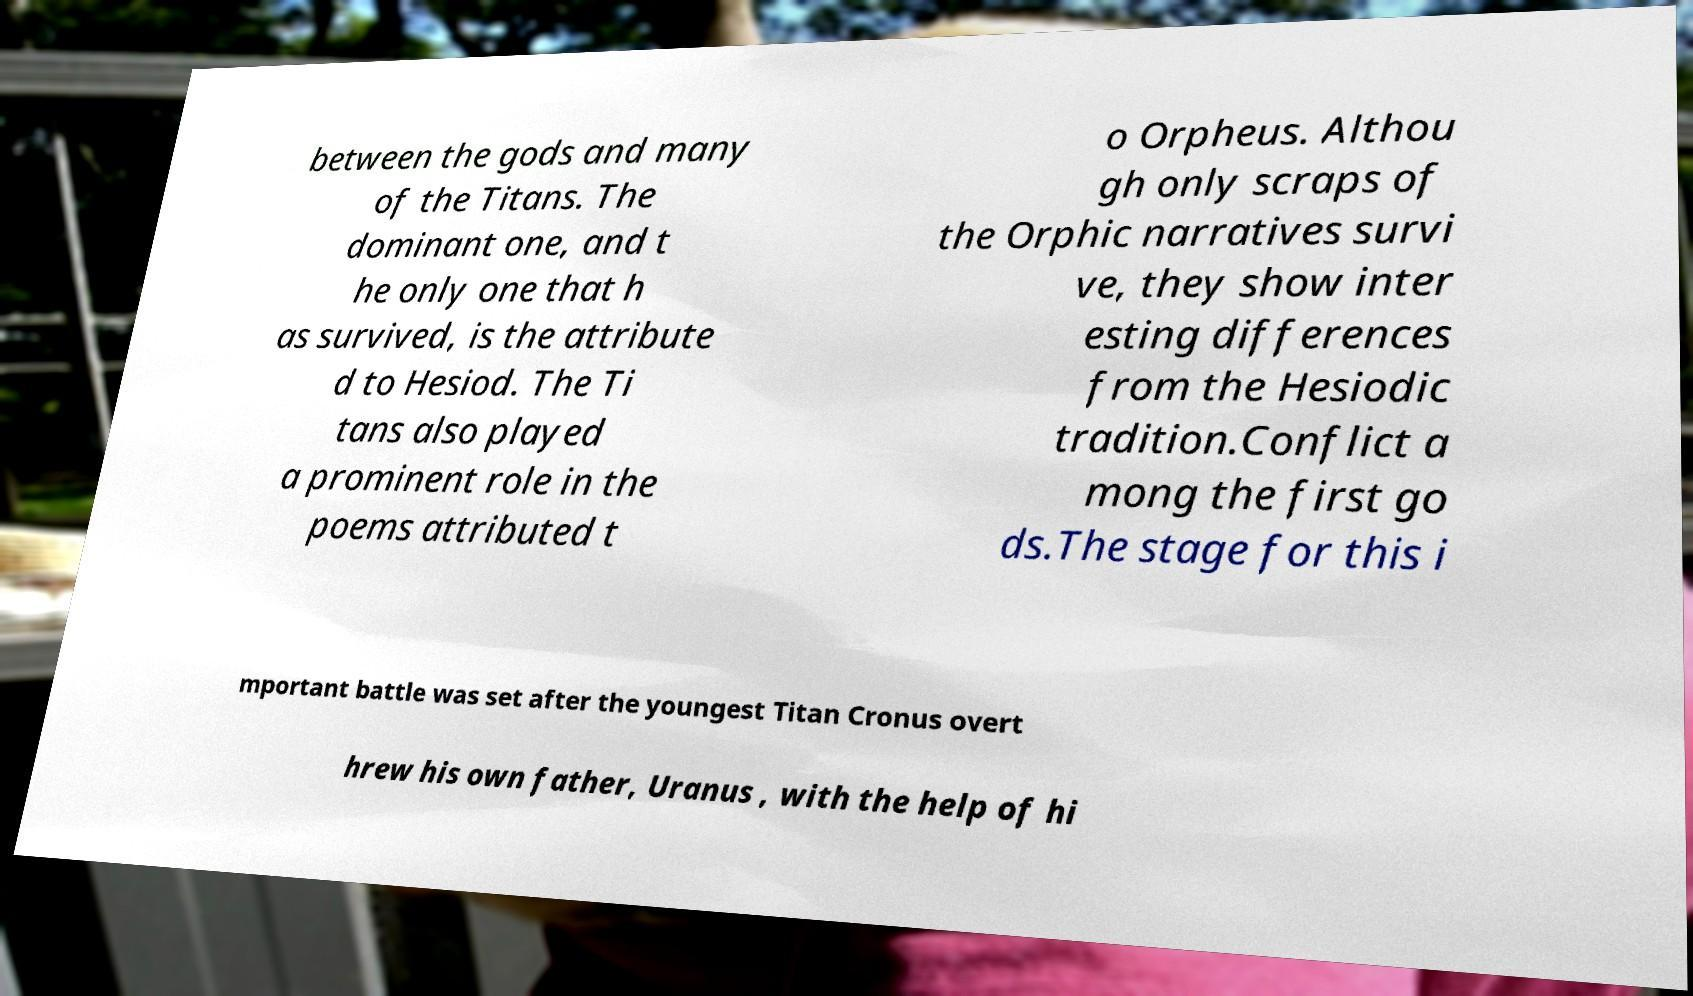Please identify and transcribe the text found in this image. between the gods and many of the Titans. The dominant one, and t he only one that h as survived, is the attribute d to Hesiod. The Ti tans also played a prominent role in the poems attributed t o Orpheus. Althou gh only scraps of the Orphic narratives survi ve, they show inter esting differences from the Hesiodic tradition.Conflict a mong the first go ds.The stage for this i mportant battle was set after the youngest Titan Cronus overt hrew his own father, Uranus , with the help of hi 